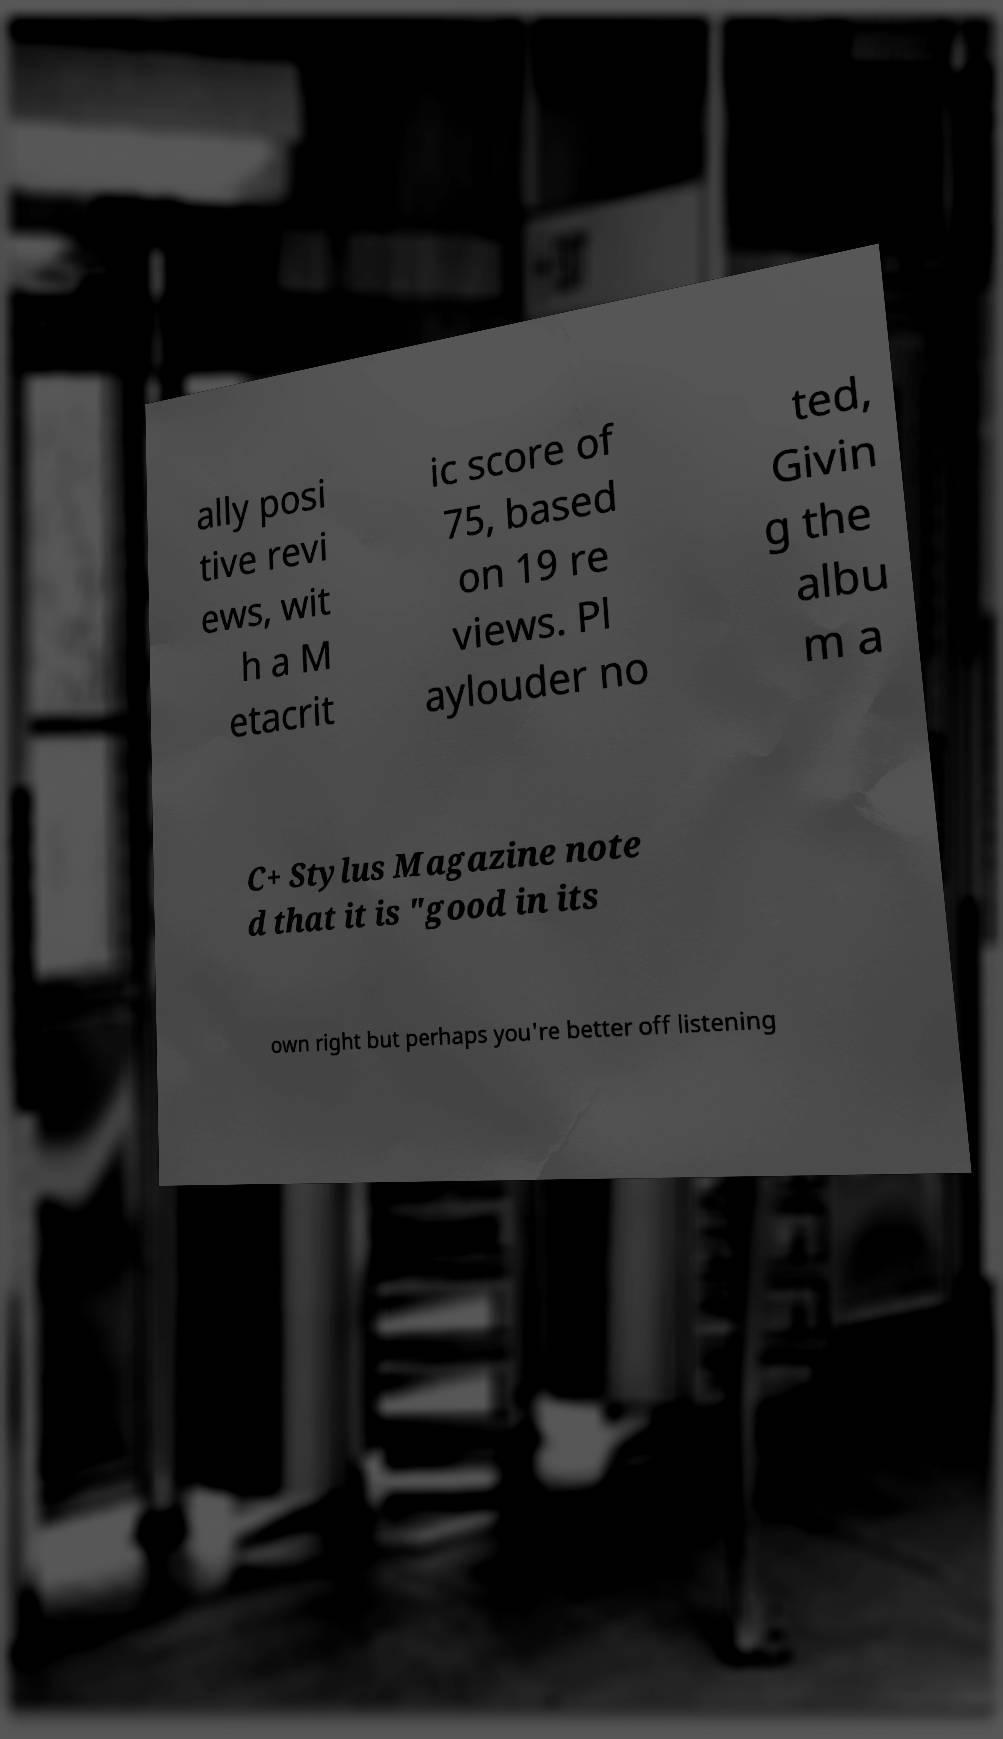Can you read and provide the text displayed in the image?This photo seems to have some interesting text. Can you extract and type it out for me? ally posi tive revi ews, wit h a M etacrit ic score of 75, based on 19 re views. Pl aylouder no ted, Givin g the albu m a C+ Stylus Magazine note d that it is "good in its own right but perhaps you're better off listening 